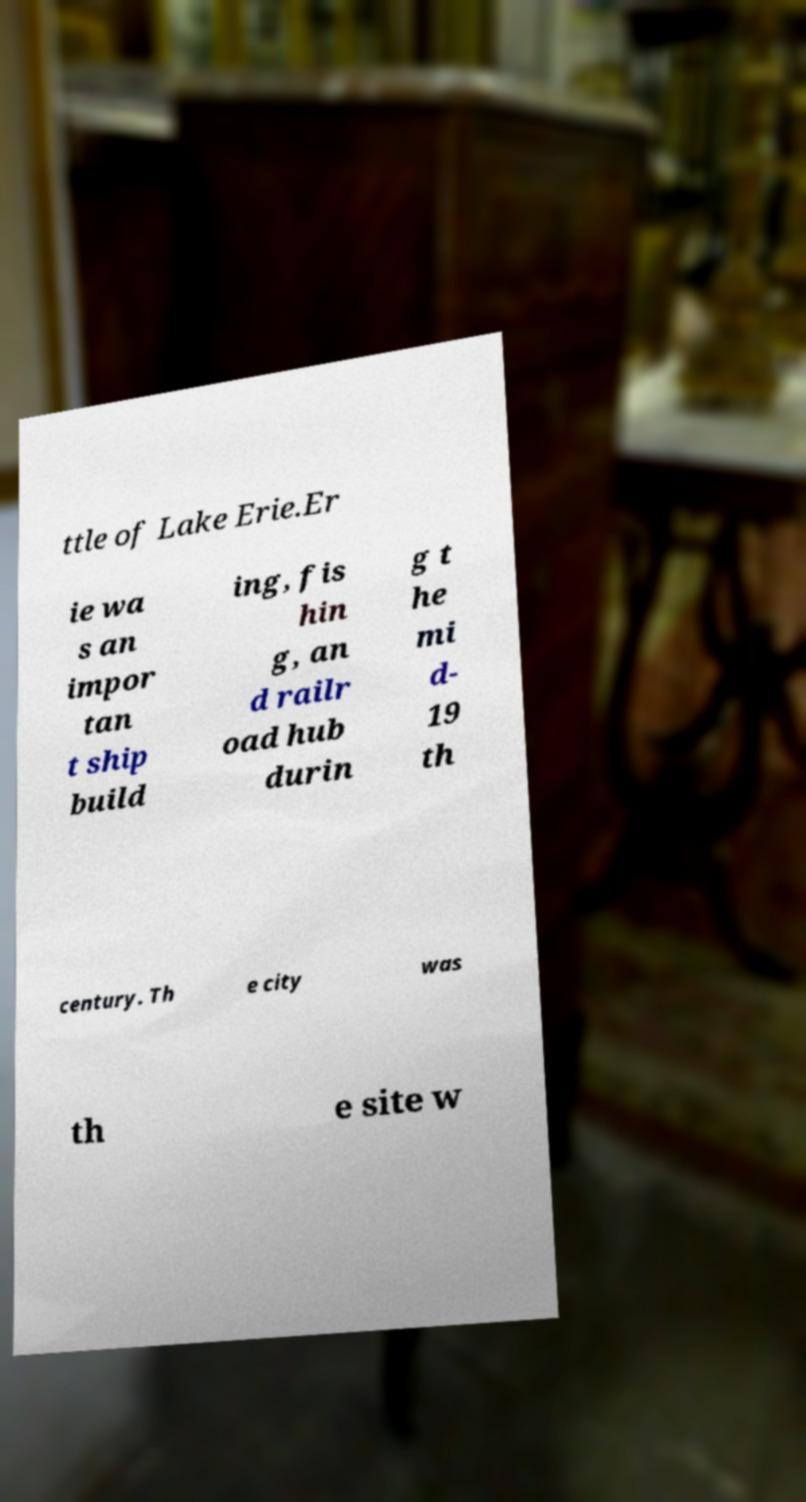Can you accurately transcribe the text from the provided image for me? ttle of Lake Erie.Er ie wa s an impor tan t ship build ing, fis hin g, an d railr oad hub durin g t he mi d- 19 th century. Th e city was th e site w 